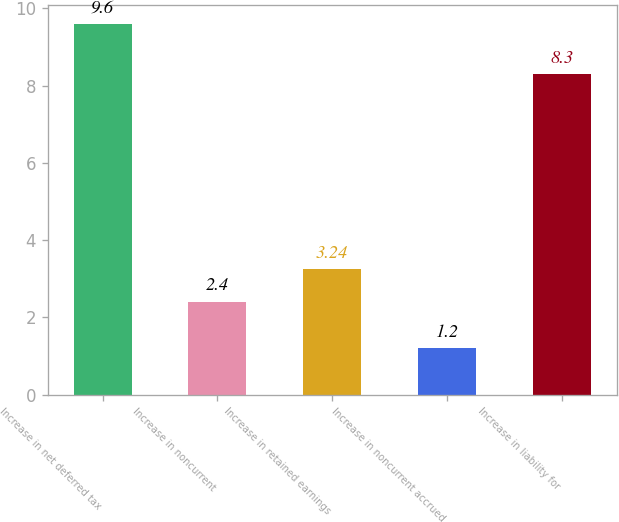<chart> <loc_0><loc_0><loc_500><loc_500><bar_chart><fcel>Increase in net deferred tax<fcel>Increase in noncurrent<fcel>Increase in retained earnings<fcel>Increase in noncurrent accrued<fcel>Increase in liability for<nl><fcel>9.6<fcel>2.4<fcel>3.24<fcel>1.2<fcel>8.3<nl></chart> 